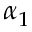Convert formula to latex. <formula><loc_0><loc_0><loc_500><loc_500>\alpha _ { 1 }</formula> 